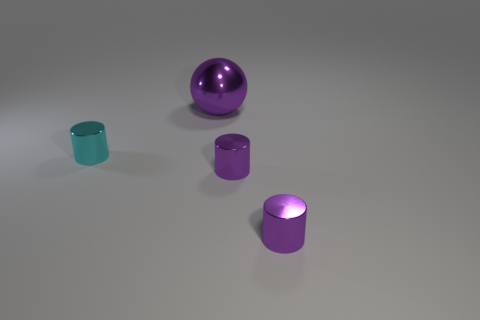Is there any other thing that has the same shape as the large purple thing?
Offer a terse response. No. Are there an equal number of tiny metallic cylinders that are right of the cyan cylinder and large things?
Offer a terse response. No. There is a big object; are there any cyan metallic things to the right of it?
Offer a terse response. No. There is a purple thing behind the thing on the left side of the purple object behind the tiny cyan object; how big is it?
Your response must be concise. Large. Do the object that is behind the tiny cyan shiny cylinder and the metal object on the left side of the big purple sphere have the same shape?
Keep it short and to the point. No. What number of small purple objects have the same material as the big sphere?
Offer a terse response. 2. What is the material of the big purple thing?
Give a very brief answer. Metal. There is a tiny metallic thing left of the purple thing that is behind the cyan metallic object; what is its shape?
Your answer should be very brief. Cylinder. What is the shape of the metal object that is behind the tiny cyan metallic thing?
Your response must be concise. Sphere. How many tiny metal things are the same color as the metal sphere?
Offer a very short reply. 2. 